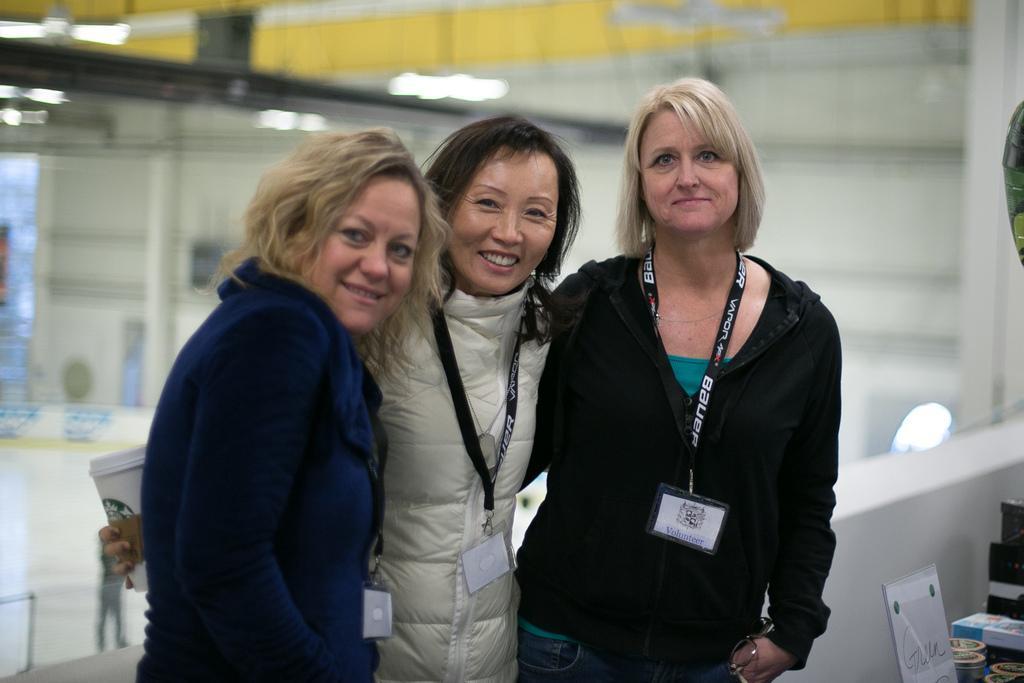Please provide a concise description of this image. In this image there are three persons standing, a person holding a cup, and there are some objects on the right side corner , and there is blur background. 